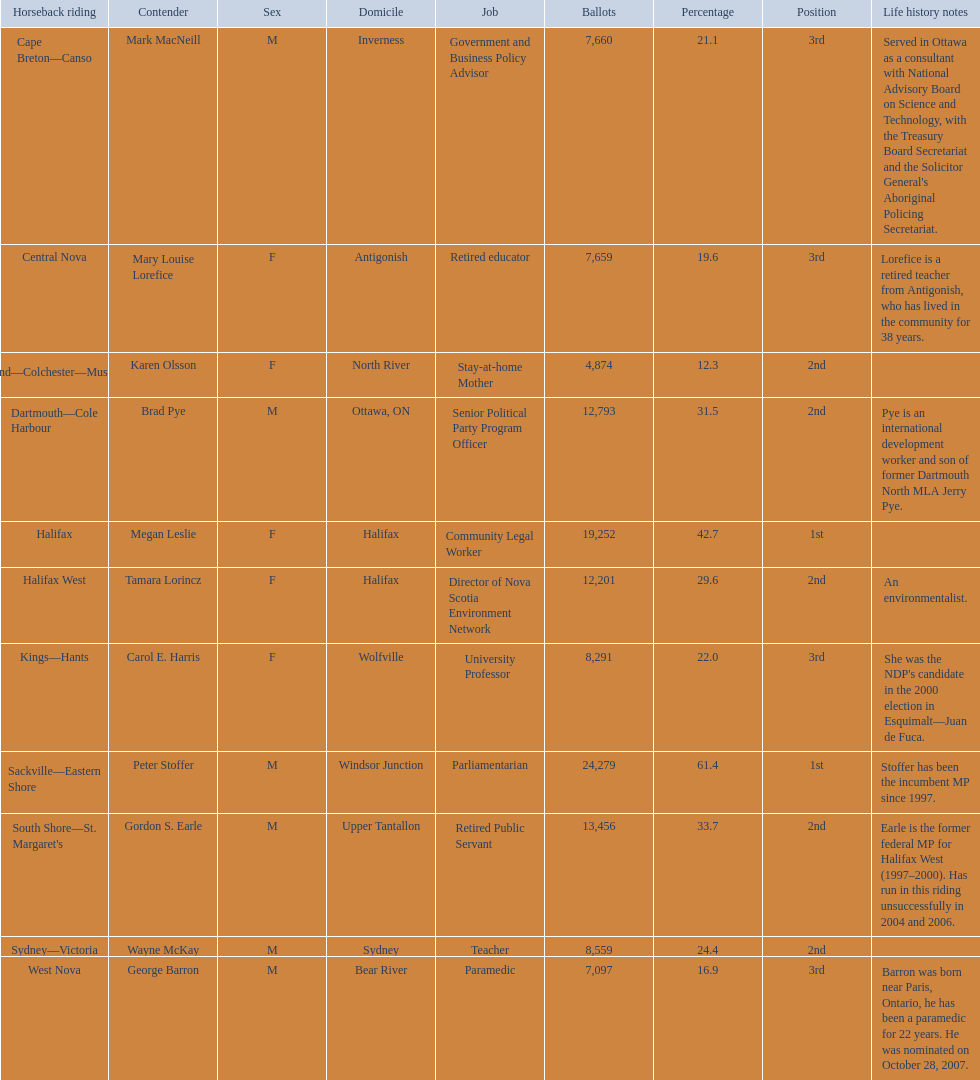Which candidates have the four lowest amount of votes Mark MacNeill, Mary Louise Lorefice, Karen Olsson, George Barron. Out of the following, who has the third most? Mark MacNeill. 